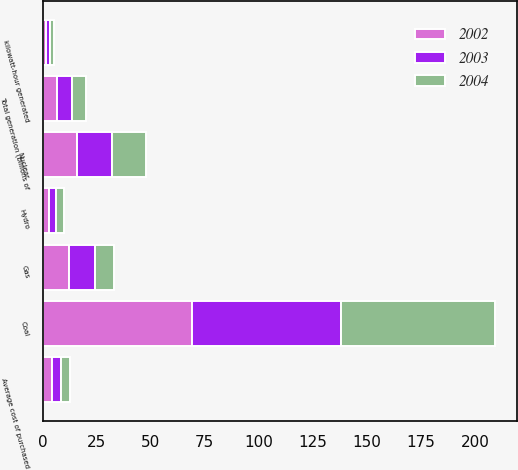Convert chart to OTSL. <chart><loc_0><loc_0><loc_500><loc_500><stacked_bar_chart><ecel><fcel>Total generation (billions of<fcel>Coal<fcel>Nuclear<fcel>Gas<fcel>Hydro<fcel>kilowatt-hour generated<fcel>Average cost of purchased<nl><fcel>2003<fcel>6.74<fcel>69<fcel>16<fcel>12<fcel>3<fcel>1.87<fcel>4.48<nl><fcel>2004<fcel>6.74<fcel>71<fcel>16<fcel>9<fcel>4<fcel>1.66<fcel>3.86<nl><fcel>2002<fcel>6.74<fcel>69<fcel>16<fcel>12<fcel>3<fcel>1.58<fcel>4.17<nl></chart> 